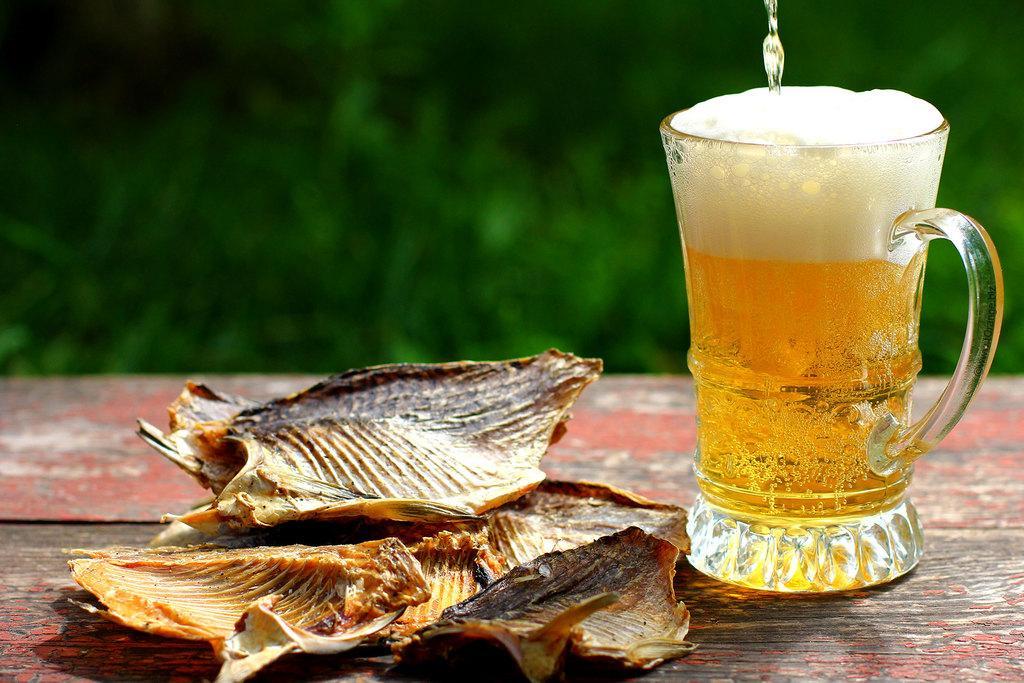Can you describe this image briefly? In this picture, we see a glass containing the liquid and a something which look like the fried dishes are placed on the red color wooden table. In the background, it is green in color. This picture is blurred in the background. 